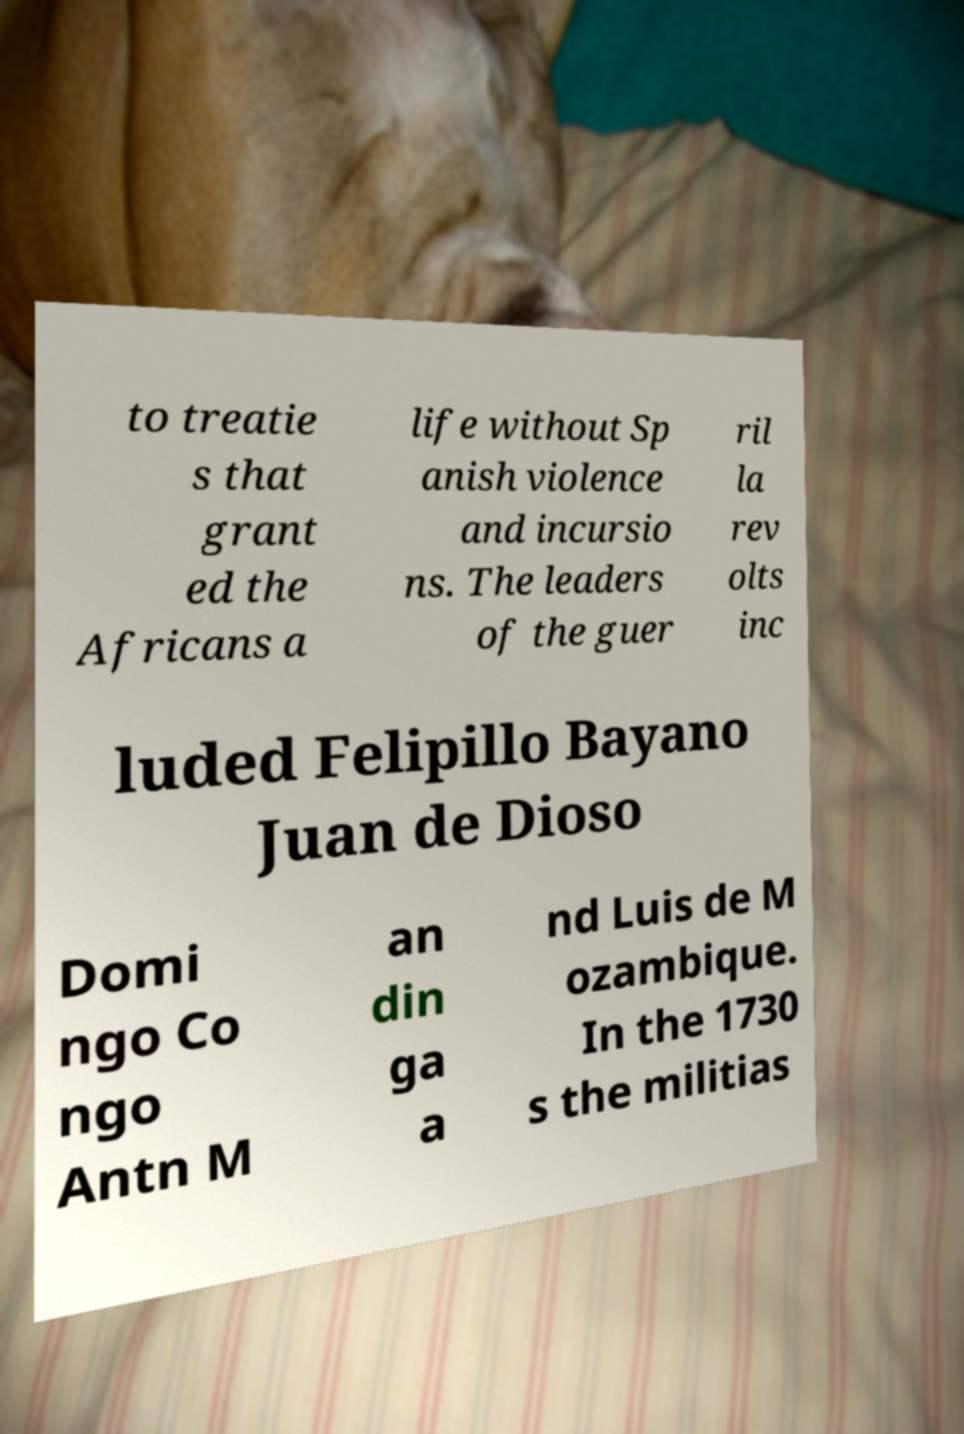What messages or text are displayed in this image? I need them in a readable, typed format. to treatie s that grant ed the Africans a life without Sp anish violence and incursio ns. The leaders of the guer ril la rev olts inc luded Felipillo Bayano Juan de Dioso Domi ngo Co ngo Antn M an din ga a nd Luis de M ozambique. In the 1730 s the militias 